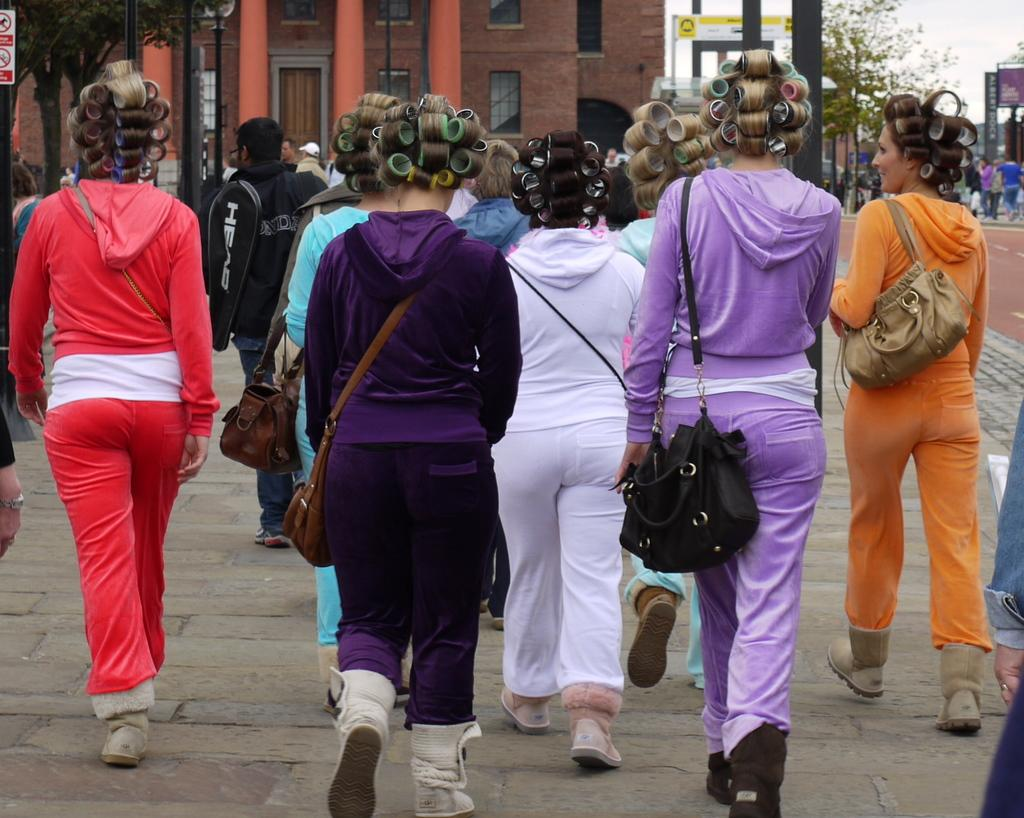How many girls are in the image? There are multiple girls in the image. What are the girls doing in the image? The girls are walking towards a building. What are the girls wearing in the image? The girls are wearing costumes of the same type, but in different colors. What are the girls carrying in the image? The girls are carrying handbags. What type of beef is being served at the event in the image? There is no event or beef present in the image; it features multiple girls walking towards a building while wearing costumes and carrying handbags. What word is written on the girls' costumes in the image? There is no word visible on the girls' costumes in the image. 